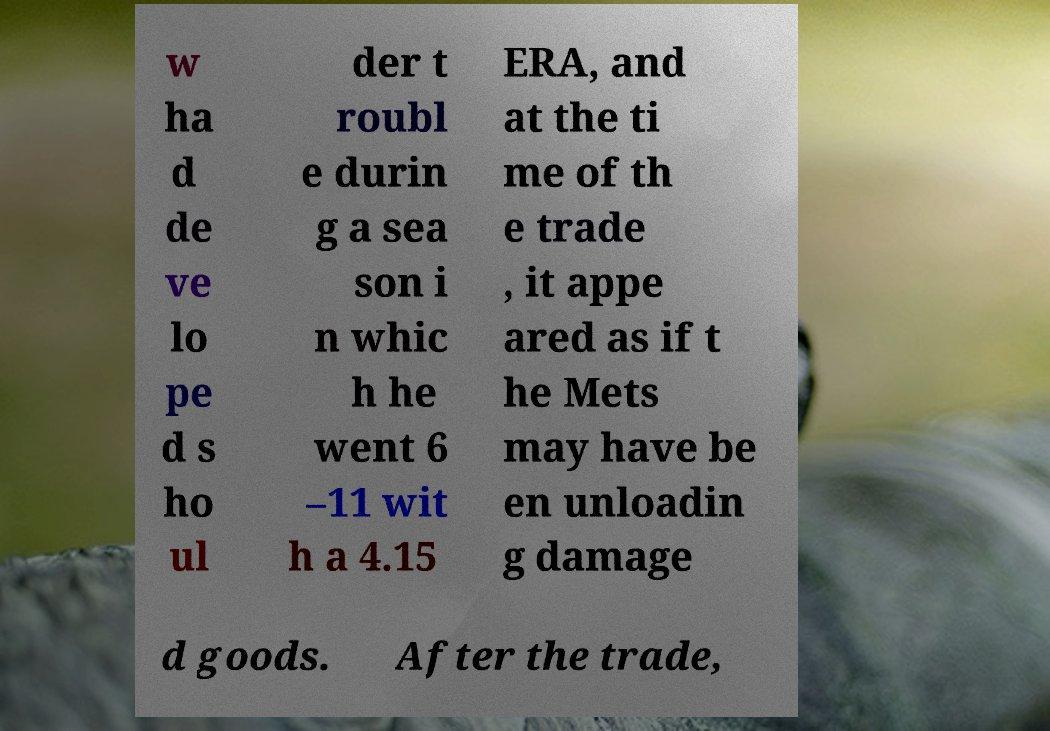Please identify and transcribe the text found in this image. w ha d de ve lo pe d s ho ul der t roubl e durin g a sea son i n whic h he went 6 –11 wit h a 4.15 ERA, and at the ti me of th e trade , it appe ared as if t he Mets may have be en unloadin g damage d goods. After the trade, 